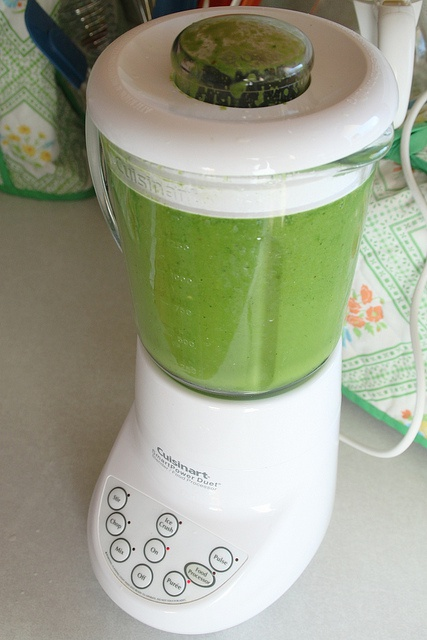Describe the objects in this image and their specific colors. I can see various objects in this image with different colors. 